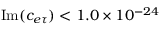Convert formula to latex. <formula><loc_0><loc_0><loc_500><loc_500>I m ( c _ { e \tau } ) < 1 . 0 \times 1 0 ^ { - 2 4 }</formula> 